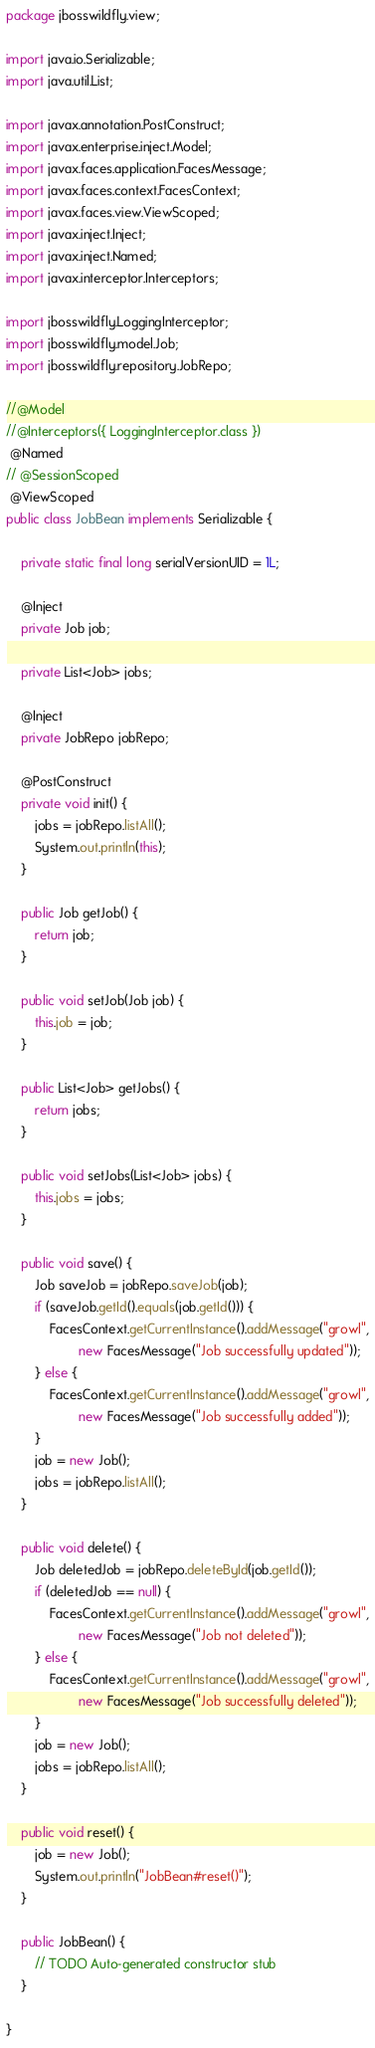<code> <loc_0><loc_0><loc_500><loc_500><_Java_>package jbosswildfly.view;

import java.io.Serializable;
import java.util.List;

import javax.annotation.PostConstruct;
import javax.enterprise.inject.Model;
import javax.faces.application.FacesMessage;
import javax.faces.context.FacesContext;
import javax.faces.view.ViewScoped;
import javax.inject.Inject;
import javax.inject.Named;
import javax.interceptor.Interceptors;

import jbosswildfly.LoggingInterceptor;
import jbosswildfly.model.Job;
import jbosswildfly.repository.JobRepo;

//@Model
//@Interceptors({ LoggingInterceptor.class })
 @Named
// @SessionScoped
 @ViewScoped
public class JobBean implements Serializable {

	private static final long serialVersionUID = 1L;

	@Inject
	private Job job;

	private List<Job> jobs;

	@Inject
	private JobRepo jobRepo;

	@PostConstruct
	private void init() {
		jobs = jobRepo.listAll();
		System.out.println(this);
	}

	public Job getJob() {
		return job;
	}

	public void setJob(Job job) {
		this.job = job;
	}

	public List<Job> getJobs() {
		return jobs;
	}

	public void setJobs(List<Job> jobs) {
		this.jobs = jobs;
	}

	public void save() {
		Job saveJob = jobRepo.saveJob(job);
		if (saveJob.getId().equals(job.getId())) {
			FacesContext.getCurrentInstance().addMessage("growl",
					new FacesMessage("Job successfully updated"));
		} else {
			FacesContext.getCurrentInstance().addMessage("growl",
					new FacesMessage("Job successfully added"));
		}
		job = new Job();
		jobs = jobRepo.listAll();
	}

	public void delete() {
		Job deletedJob = jobRepo.deleteById(job.getId());
		if (deletedJob == null) {
			FacesContext.getCurrentInstance().addMessage("growl",
					new FacesMessage("Job not deleted"));
		} else {
			FacesContext.getCurrentInstance().addMessage("growl",
					new FacesMessage("Job successfully deleted"));
		}
		job = new Job();
		jobs = jobRepo.listAll();
	}

	public void reset() {
		job = new Job();
		System.out.println("JobBean#reset()");
	}

	public JobBean() {
		// TODO Auto-generated constructor stub
	}

}
</code> 